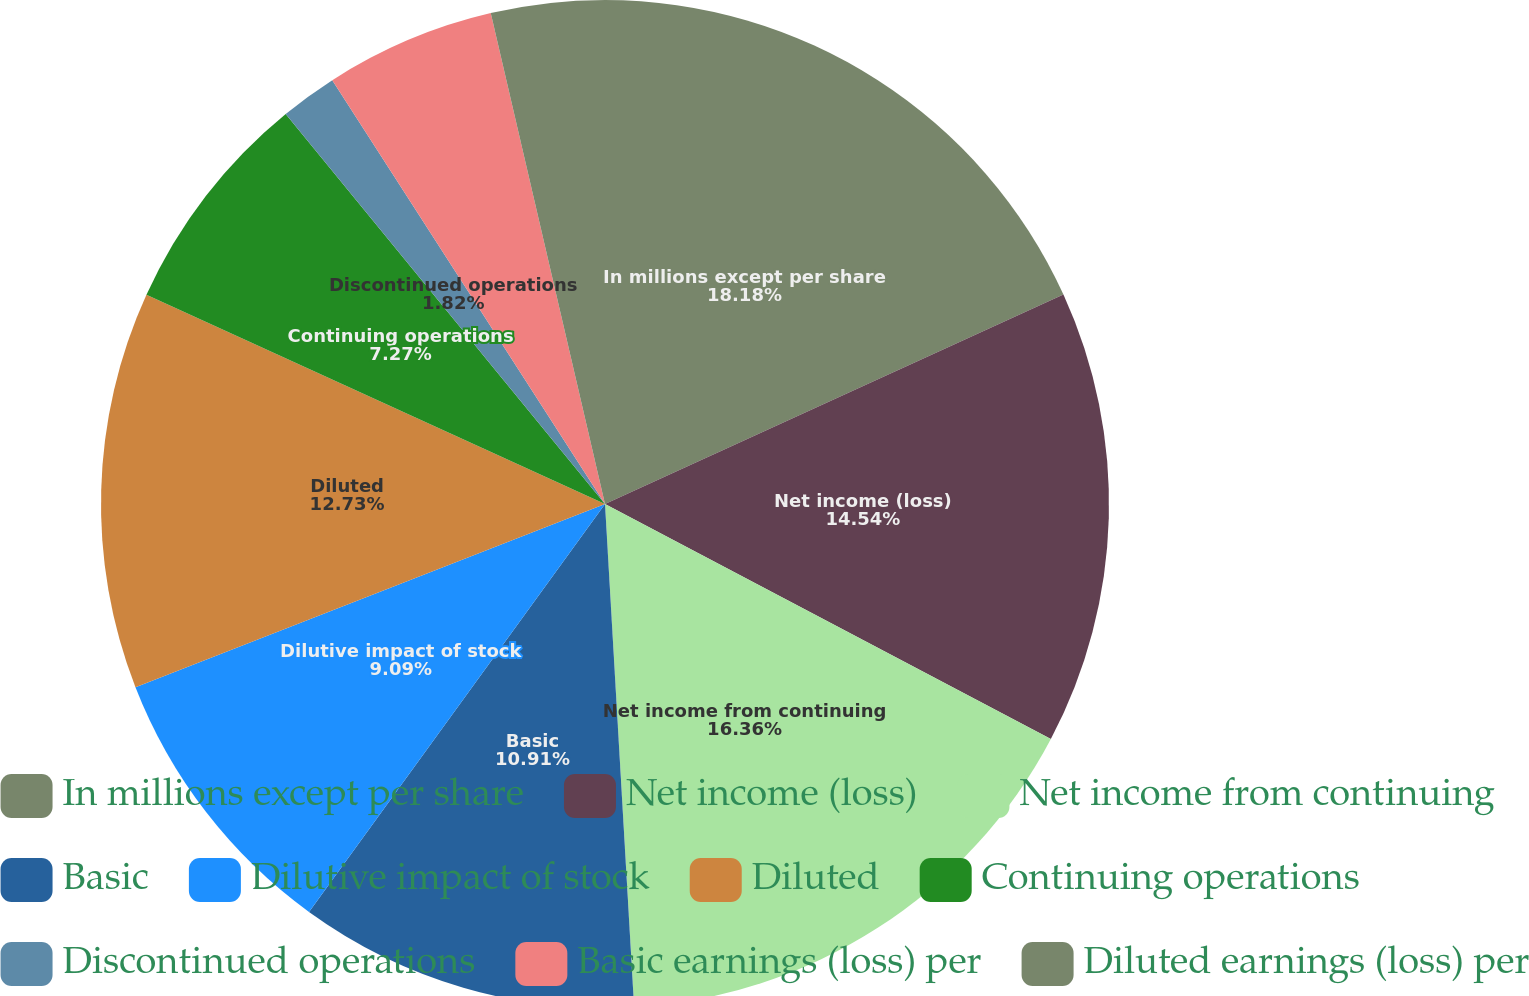Convert chart. <chart><loc_0><loc_0><loc_500><loc_500><pie_chart><fcel>In millions except per share<fcel>Net income (loss)<fcel>Net income from continuing<fcel>Basic<fcel>Dilutive impact of stock<fcel>Diluted<fcel>Continuing operations<fcel>Discontinued operations<fcel>Basic earnings (loss) per<fcel>Diluted earnings (loss) per<nl><fcel>18.18%<fcel>14.54%<fcel>16.36%<fcel>10.91%<fcel>9.09%<fcel>12.73%<fcel>7.27%<fcel>1.82%<fcel>5.46%<fcel>3.64%<nl></chart> 